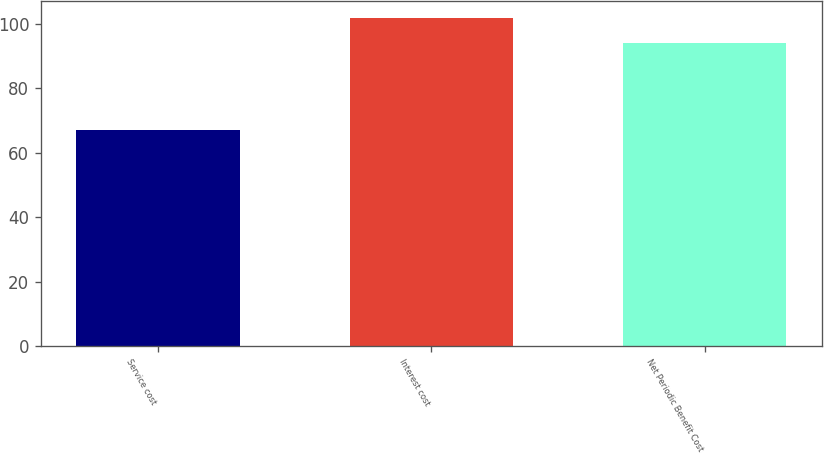Convert chart to OTSL. <chart><loc_0><loc_0><loc_500><loc_500><bar_chart><fcel>Service cost<fcel>Interest cost<fcel>Net Periodic Benefit Cost<nl><fcel>67<fcel>102<fcel>94<nl></chart> 